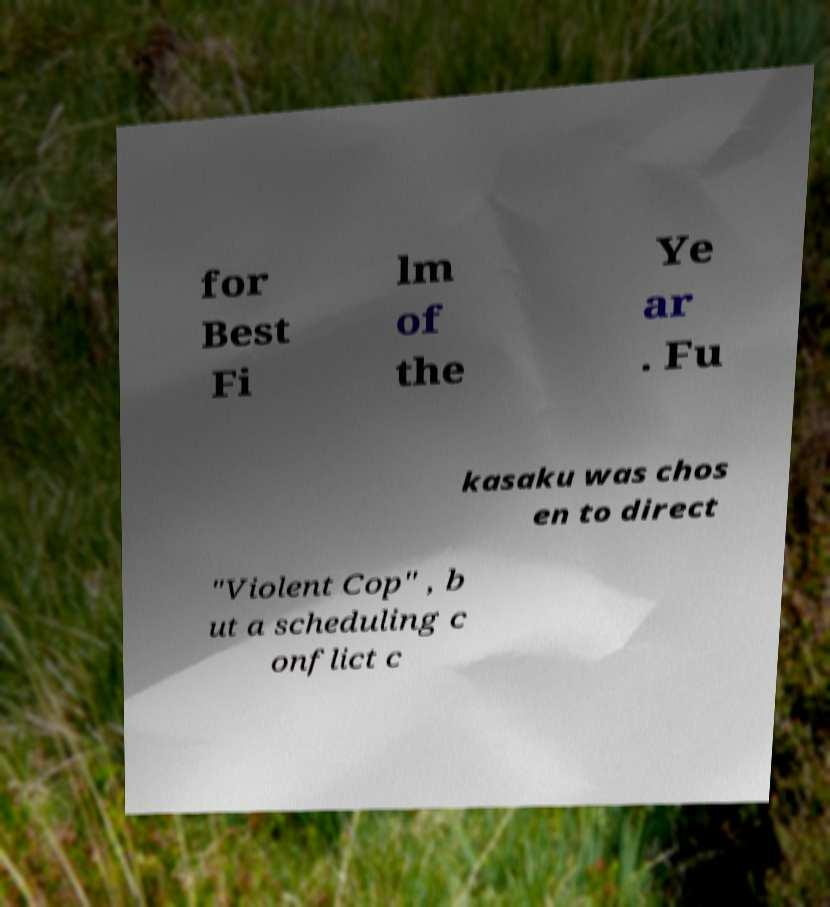There's text embedded in this image that I need extracted. Can you transcribe it verbatim? for Best Fi lm of the Ye ar . Fu kasaku was chos en to direct "Violent Cop" , b ut a scheduling c onflict c 